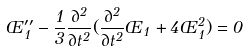<formula> <loc_0><loc_0><loc_500><loc_500>\phi _ { 1 } ^ { \prime \prime } - \frac { 1 } { 3 } \frac { \partial ^ { 2 } } { \partial t ^ { 2 } } ( \frac { \partial ^ { 2 } } { \partial t ^ { 2 } } \phi _ { 1 } + 4 \phi _ { 1 } ^ { 2 } ) = 0</formula> 